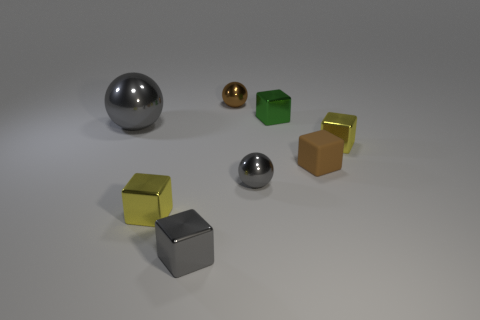What size is the gray thing that is the same shape as the tiny green object?
Give a very brief answer. Small. Are there fewer brown balls in front of the small brown rubber cube than red metallic spheres?
Keep it short and to the point. No. How many blue cubes are there?
Make the answer very short. 0. How many tiny objects are the same color as the big thing?
Your response must be concise. 2. Do the brown rubber object and the tiny green metal object have the same shape?
Provide a succinct answer. Yes. What is the size of the metallic thing on the left side of the tiny yellow thing on the left side of the small gray metallic ball?
Offer a very short reply. Large. Are there any red metallic blocks that have the same size as the gray shiny block?
Provide a succinct answer. No. Does the yellow metal thing to the right of the tiny green metal block have the same size as the gray metallic object behind the tiny gray shiny sphere?
Give a very brief answer. No. What is the shape of the tiny yellow thing that is to the left of the small brown metal ball that is behind the small matte thing?
Give a very brief answer. Cube. How many brown shiny objects are on the left side of the tiny brown metallic sphere?
Your answer should be very brief. 0. 